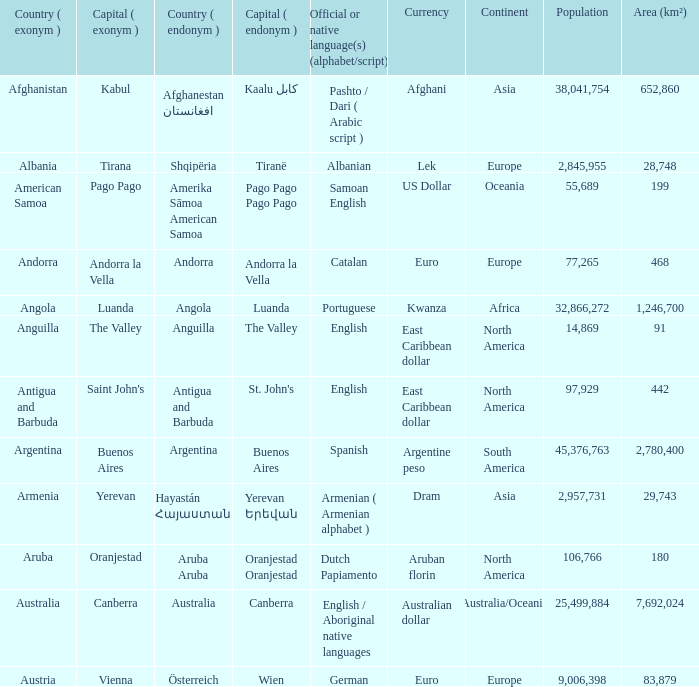What is the local name given to the city of Canberra? Canberra. 